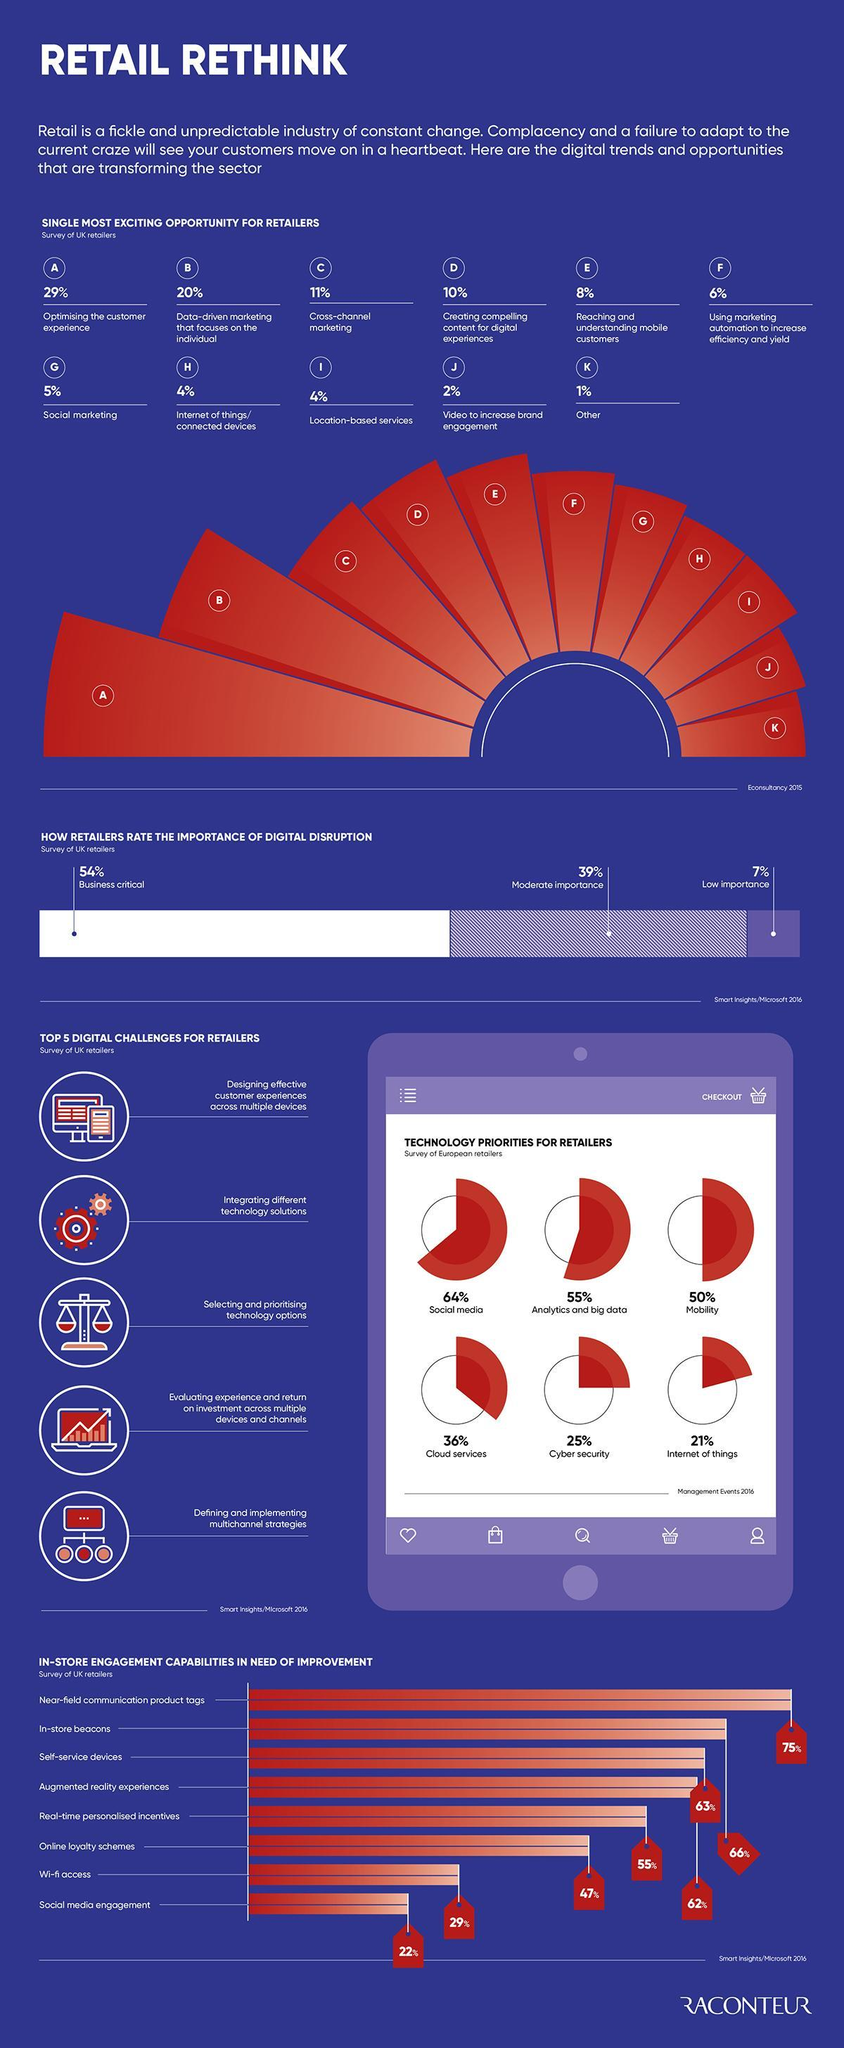What percentage of retailers need to improve their presence in social media?
Answer the question with a short phrase. 22% What percentage  of retailers think that digital services are important for their business? 54% Which digital opportunity has a higher percentage, Internet of things, Others, or Cross-channel marketing? Cross-channel marketing How many digital opportunities are their for retailers ? 11 What percentage of retailers feel that IoT is a priority for the business? 21% 